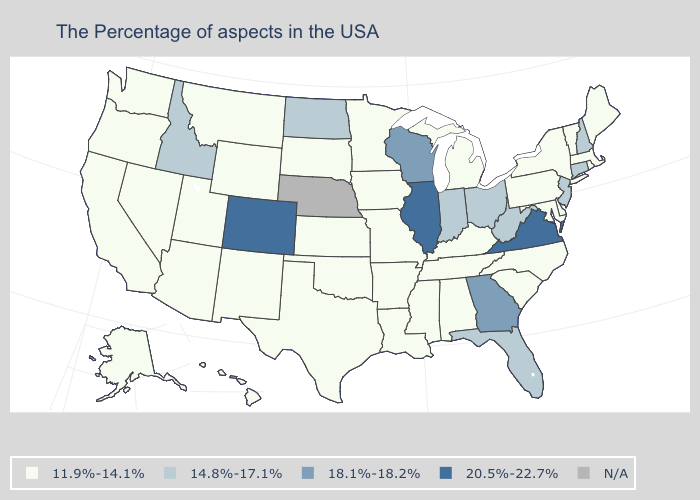Name the states that have a value in the range 11.9%-14.1%?
Short answer required. Maine, Massachusetts, Rhode Island, Vermont, New York, Delaware, Maryland, Pennsylvania, North Carolina, South Carolina, Michigan, Kentucky, Alabama, Tennessee, Mississippi, Louisiana, Missouri, Arkansas, Minnesota, Iowa, Kansas, Oklahoma, Texas, South Dakota, Wyoming, New Mexico, Utah, Montana, Arizona, Nevada, California, Washington, Oregon, Alaska, Hawaii. Does Virginia have the highest value in the USA?
Short answer required. Yes. Among the states that border South Dakota , which have the lowest value?
Be succinct. Minnesota, Iowa, Wyoming, Montana. Does Connecticut have the lowest value in the USA?
Short answer required. No. Which states have the lowest value in the MidWest?
Concise answer only. Michigan, Missouri, Minnesota, Iowa, Kansas, South Dakota. Which states have the highest value in the USA?
Keep it brief. Virginia, Illinois, Colorado. Name the states that have a value in the range 11.9%-14.1%?
Give a very brief answer. Maine, Massachusetts, Rhode Island, Vermont, New York, Delaware, Maryland, Pennsylvania, North Carolina, South Carolina, Michigan, Kentucky, Alabama, Tennessee, Mississippi, Louisiana, Missouri, Arkansas, Minnesota, Iowa, Kansas, Oklahoma, Texas, South Dakota, Wyoming, New Mexico, Utah, Montana, Arizona, Nevada, California, Washington, Oregon, Alaska, Hawaii. What is the value of Washington?
Keep it brief. 11.9%-14.1%. Name the states that have a value in the range 11.9%-14.1%?
Give a very brief answer. Maine, Massachusetts, Rhode Island, Vermont, New York, Delaware, Maryland, Pennsylvania, North Carolina, South Carolina, Michigan, Kentucky, Alabama, Tennessee, Mississippi, Louisiana, Missouri, Arkansas, Minnesota, Iowa, Kansas, Oklahoma, Texas, South Dakota, Wyoming, New Mexico, Utah, Montana, Arizona, Nevada, California, Washington, Oregon, Alaska, Hawaii. Does the map have missing data?
Write a very short answer. Yes. Name the states that have a value in the range 20.5%-22.7%?
Short answer required. Virginia, Illinois, Colorado. Among the states that border Georgia , does Florida have the highest value?
Short answer required. Yes. 